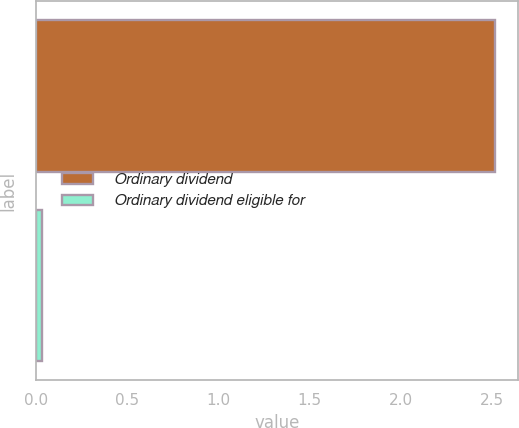Convert chart to OTSL. <chart><loc_0><loc_0><loc_500><loc_500><bar_chart><fcel>Ordinary dividend<fcel>Ordinary dividend eligible for<nl><fcel>2.52<fcel>0.03<nl></chart> 